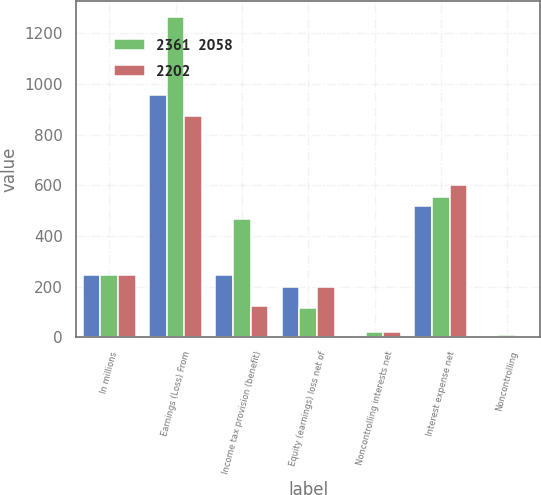<chart> <loc_0><loc_0><loc_500><loc_500><stacked_bar_chart><ecel><fcel>In millions<fcel>Earnings (Loss) From<fcel>Income tax provision (benefit)<fcel>Equity (earnings) loss net of<fcel>Noncontrolling interests net<fcel>Interest expense net<fcel>Noncontrolling<nl><fcel>nan<fcel>247<fcel>956<fcel>247<fcel>198<fcel>2<fcel>520<fcel>1<nl><fcel>2361  2058<fcel>247<fcel>1266<fcel>466<fcel>117<fcel>21<fcel>555<fcel>8<nl><fcel>2202<fcel>247<fcel>872<fcel>123<fcel>200<fcel>19<fcel>601<fcel>2<nl></chart> 